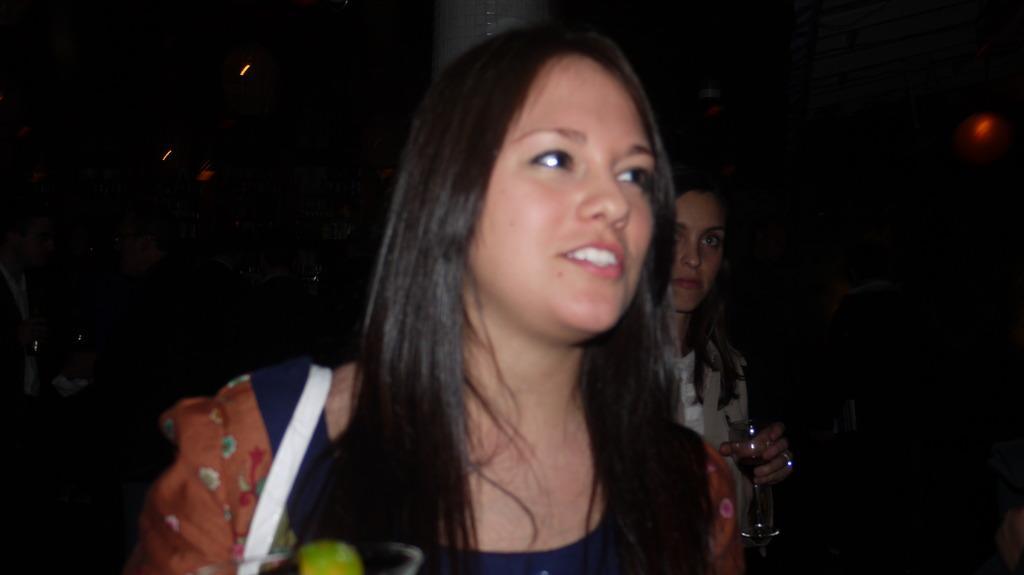Could you give a brief overview of what you see in this image? In this image I can see a person wearing different color dress and another person is holding a glass. Background is in black color. 